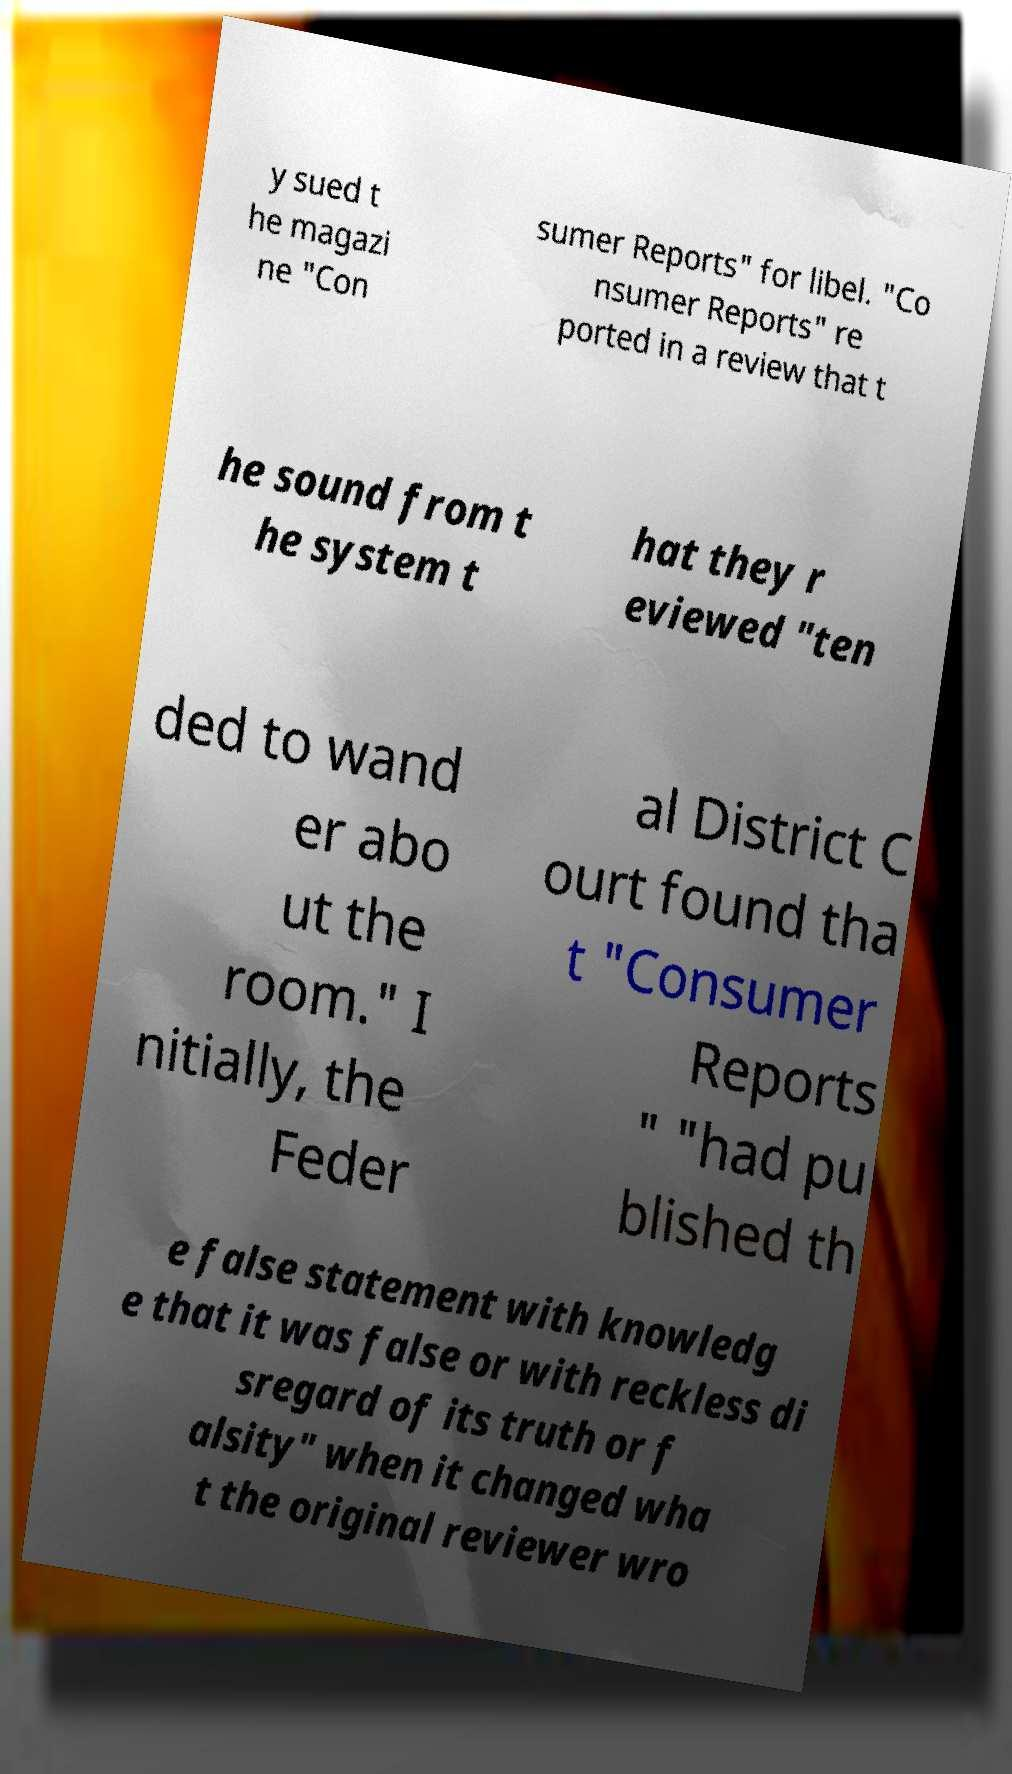Please identify and transcribe the text found in this image. y sued t he magazi ne "Con sumer Reports" for libel. "Co nsumer Reports" re ported in a review that t he sound from t he system t hat they r eviewed "ten ded to wand er abo ut the room." I nitially, the Feder al District C ourt found tha t "Consumer Reports " "had pu blished th e false statement with knowledg e that it was false or with reckless di sregard of its truth or f alsity" when it changed wha t the original reviewer wro 